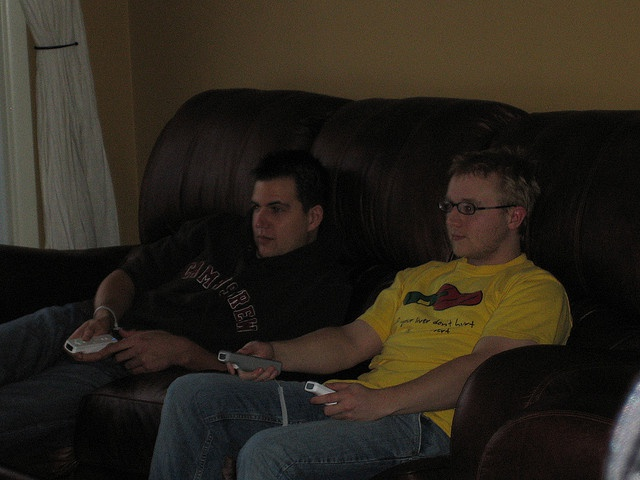Describe the objects in this image and their specific colors. I can see couch in gray, black, and darkgreen tones, people in gray, black, olive, and maroon tones, people in gray, black, and maroon tones, remote in gray and black tones, and remote in gray and black tones in this image. 